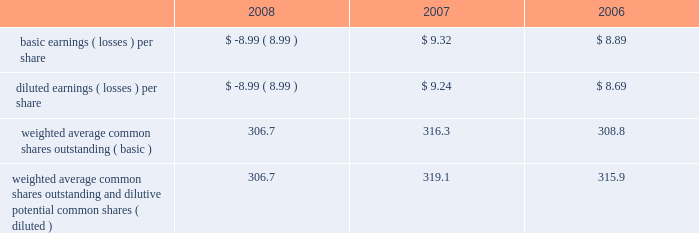Table of contents the company receives a foreign tax credit ( 201cftc 201d ) against its u.s .
Tax liability for foreign taxes paid by the company including payments from its separate account assets .
The separate account ftc is estimated for the current year using information from the most recent filed return , adjusted for the change in the allocation of separate account investments to the international equity markets during the current year .
The actual current year ftc can vary from the estimates due to actual ftcs passed through by the mutual funds .
The company recorded benefits of $ 16 , $ 11 and $ 17 related to separate account ftc in the years ended december 31 , 2008 , december 31 , 2007 and december 31 , 2006 , respectively .
These amounts included benefits related to true- ups of prior years 2019 tax returns of $ 4 , $ 0 and $ 7 in 2008 , 2007 and 2006 respectively .
The company 2019s unrecognized tax benefits increased by $ 15 during 2008 as a result of tax positions taken on the company 2019s 2007 tax return and expected to be taken on its 2008 tax return , bringing the total unrecognized tax benefits to $ 91 as of december 31 , 2008 .
This entire amount , if it were recognized , would affect the effective tax rate .
Earnings ( losses ) per common share the table represents earnings per common share data for the past three years : for additional information on earnings ( losses ) per common share see note 2 of notes to consolidated financial statements .
Outlooks the hartford provides projections and other forward-looking information in the 201coutlook 201d sections within md&a .
The 201coutlook 201d sections contain many forward-looking statements , particularly relating to the company 2019s future financial performance .
These forward-looking statements are estimates based on information currently available to the company , are made pursuant to the safe harbor provisions of the private securities litigation reform act of 1995 and are subject to the precautionary statements set forth in the introduction to md&a above .
Actual results are likely to differ , and in the past have differed , materially from those forecast by the company , depending on the outcome of various factors , including , but not limited to , those set forth in each 201coutlook 201d section and in item 1a , risk factors .
Outlook during 2008 , the company has been negatively impacted by conditions in the global financial markets and economic conditions in general .
As these conditions persist in 2009 , the company would anticipate that it would continue to be negatively impacted , including the effect of rating downgrades that have occurred and those that could occur in the future .
See risk factors in item 1a .
Retail in the long-term , management continues to believe the market for retirement products will expand as individuals increasingly save and plan for retirement .
Demographic trends suggest that as the 201cbaby boom 201d generation matures , a significant portion of the united states population will allocate a greater percentage of their disposable incomes to saving for their retirement years due to uncertainty surrounding the social security system and increases in average life expectancy .
Near-term , the industry and the company are experiencing lower variable annuity sales as a result of recent market turbulence and uncertainty in the u.s .
Financial system .
Current market pressures are also increasing the expected claim costs , the cost and volatility of hedging programs , and the level of capital needed to support living benefit guarantees .
Some companies have already begun to increase the price of their guaranteed living benefits and change the level of guarantees offered .
In 2009 , the company intends to adjust pricing levels and take certain actions to reduce the risks in its variable annuity product features in order to address the risks and costs associated with variable annuity benefit features in the current economic environment and explore other risk limiting techniques such as increased hedging or other reinsurance structures .
Competitor reaction , including the extent of competitor risk limiting strategies , is difficult to predict and may result in a decline in retail 2019s market share .
Significant declines in equity markets and increased equity market volatility are also likely to continue to impact the cost and effectiveness of our gmwb hedging program .
Continued equity market volatility could result in material losses in our hedging program .
For more information on the gmwb hedging program , see the equity risk management section within capital markets risk management .
During periods of volatile equity markets , policyholders may allocate more of their variable account assets to the fixed account options and fixed annuities may see increased deposits .
In the fourth quarter of 2008 , the company has seen an increase in fixed .
Weighted average common shares outstanding and dilutive potential common shares ( diluted ) 306.7 319.1 315.9 .
What is the net income reported in 2008 , ( in millions ) ? 
Computations: (306.7 * -8.99)
Answer: -2757.233. 